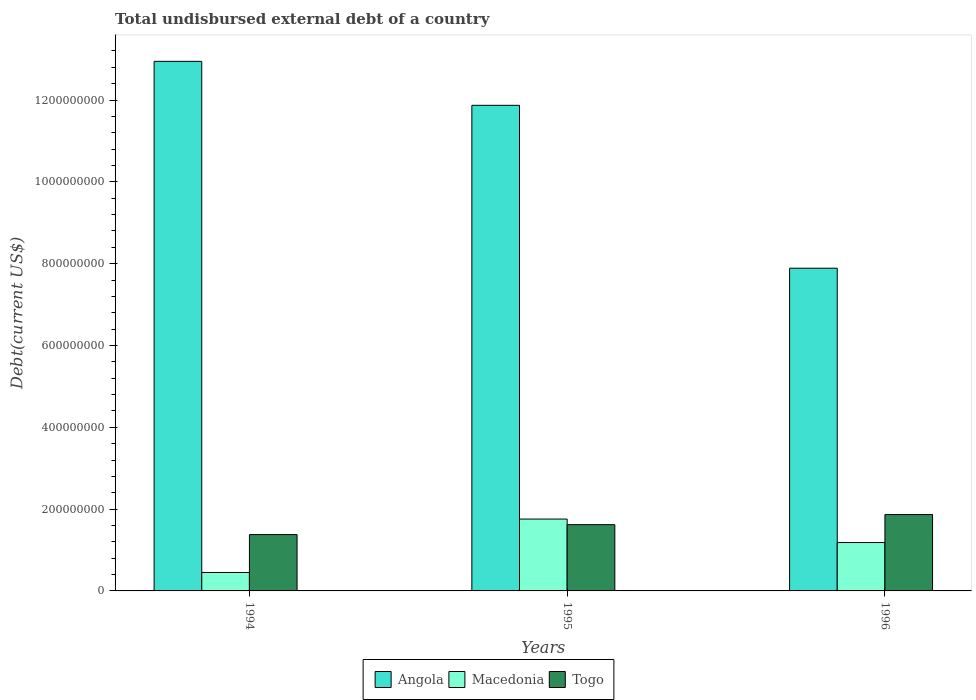How many different coloured bars are there?
Your answer should be very brief. 3. How many groups of bars are there?
Your response must be concise. 3. Are the number of bars per tick equal to the number of legend labels?
Your answer should be compact. Yes. Are the number of bars on each tick of the X-axis equal?
Ensure brevity in your answer.  Yes. How many bars are there on the 3rd tick from the right?
Your response must be concise. 3. What is the label of the 1st group of bars from the left?
Your answer should be compact. 1994. What is the total undisbursed external debt in Macedonia in 1996?
Offer a very short reply. 1.18e+08. Across all years, what is the maximum total undisbursed external debt in Togo?
Your answer should be compact. 1.87e+08. Across all years, what is the minimum total undisbursed external debt in Angola?
Ensure brevity in your answer.  7.89e+08. In which year was the total undisbursed external debt in Angola maximum?
Keep it short and to the point. 1994. What is the total total undisbursed external debt in Angola in the graph?
Provide a succinct answer. 3.27e+09. What is the difference between the total undisbursed external debt in Togo in 1994 and that in 1996?
Give a very brief answer. -4.90e+07. What is the difference between the total undisbursed external debt in Togo in 1994 and the total undisbursed external debt in Macedonia in 1995?
Offer a very short reply. -3.80e+07. What is the average total undisbursed external debt in Togo per year?
Offer a very short reply. 1.62e+08. In the year 1995, what is the difference between the total undisbursed external debt in Angola and total undisbursed external debt in Togo?
Provide a succinct answer. 1.03e+09. What is the ratio of the total undisbursed external debt in Macedonia in 1995 to that in 1996?
Provide a succinct answer. 1.49. Is the difference between the total undisbursed external debt in Angola in 1994 and 1996 greater than the difference between the total undisbursed external debt in Togo in 1994 and 1996?
Offer a very short reply. Yes. What is the difference between the highest and the second highest total undisbursed external debt in Togo?
Your answer should be compact. 2.47e+07. What is the difference between the highest and the lowest total undisbursed external debt in Macedonia?
Your answer should be compact. 1.31e+08. In how many years, is the total undisbursed external debt in Togo greater than the average total undisbursed external debt in Togo taken over all years?
Provide a short and direct response. 1. Is the sum of the total undisbursed external debt in Togo in 1994 and 1996 greater than the maximum total undisbursed external debt in Macedonia across all years?
Make the answer very short. Yes. What does the 3rd bar from the left in 1995 represents?
Give a very brief answer. Togo. What does the 2nd bar from the right in 1996 represents?
Offer a terse response. Macedonia. Is it the case that in every year, the sum of the total undisbursed external debt in Togo and total undisbursed external debt in Macedonia is greater than the total undisbursed external debt in Angola?
Keep it short and to the point. No. How many bars are there?
Keep it short and to the point. 9. What is the difference between two consecutive major ticks on the Y-axis?
Give a very brief answer. 2.00e+08. Does the graph contain any zero values?
Ensure brevity in your answer.  No. How many legend labels are there?
Make the answer very short. 3. What is the title of the graph?
Offer a very short reply. Total undisbursed external debt of a country. Does "Sub-Saharan Africa (developing only)" appear as one of the legend labels in the graph?
Ensure brevity in your answer.  No. What is the label or title of the Y-axis?
Your answer should be compact. Debt(current US$). What is the Debt(current US$) in Angola in 1994?
Give a very brief answer. 1.29e+09. What is the Debt(current US$) in Macedonia in 1994?
Your answer should be very brief. 4.51e+07. What is the Debt(current US$) in Togo in 1994?
Give a very brief answer. 1.38e+08. What is the Debt(current US$) in Angola in 1995?
Give a very brief answer. 1.19e+09. What is the Debt(current US$) of Macedonia in 1995?
Provide a short and direct response. 1.76e+08. What is the Debt(current US$) in Togo in 1995?
Ensure brevity in your answer.  1.62e+08. What is the Debt(current US$) in Angola in 1996?
Provide a succinct answer. 7.89e+08. What is the Debt(current US$) in Macedonia in 1996?
Keep it short and to the point. 1.18e+08. What is the Debt(current US$) in Togo in 1996?
Offer a very short reply. 1.87e+08. Across all years, what is the maximum Debt(current US$) in Angola?
Provide a short and direct response. 1.29e+09. Across all years, what is the maximum Debt(current US$) in Macedonia?
Give a very brief answer. 1.76e+08. Across all years, what is the maximum Debt(current US$) of Togo?
Keep it short and to the point. 1.87e+08. Across all years, what is the minimum Debt(current US$) in Angola?
Offer a terse response. 7.89e+08. Across all years, what is the minimum Debt(current US$) in Macedonia?
Your answer should be very brief. 4.51e+07. Across all years, what is the minimum Debt(current US$) of Togo?
Your response must be concise. 1.38e+08. What is the total Debt(current US$) in Angola in the graph?
Ensure brevity in your answer.  3.27e+09. What is the total Debt(current US$) in Macedonia in the graph?
Offer a very short reply. 3.39e+08. What is the total Debt(current US$) in Togo in the graph?
Your answer should be very brief. 4.86e+08. What is the difference between the Debt(current US$) of Angola in 1994 and that in 1995?
Offer a very short reply. 1.07e+08. What is the difference between the Debt(current US$) in Macedonia in 1994 and that in 1995?
Offer a very short reply. -1.31e+08. What is the difference between the Debt(current US$) in Togo in 1994 and that in 1995?
Your answer should be compact. -2.43e+07. What is the difference between the Debt(current US$) in Angola in 1994 and that in 1996?
Your answer should be compact. 5.06e+08. What is the difference between the Debt(current US$) in Macedonia in 1994 and that in 1996?
Offer a terse response. -7.32e+07. What is the difference between the Debt(current US$) of Togo in 1994 and that in 1996?
Give a very brief answer. -4.90e+07. What is the difference between the Debt(current US$) of Angola in 1995 and that in 1996?
Give a very brief answer. 3.98e+08. What is the difference between the Debt(current US$) in Macedonia in 1995 and that in 1996?
Keep it short and to the point. 5.74e+07. What is the difference between the Debt(current US$) of Togo in 1995 and that in 1996?
Keep it short and to the point. -2.47e+07. What is the difference between the Debt(current US$) of Angola in 1994 and the Debt(current US$) of Macedonia in 1995?
Ensure brevity in your answer.  1.12e+09. What is the difference between the Debt(current US$) of Angola in 1994 and the Debt(current US$) of Togo in 1995?
Your response must be concise. 1.13e+09. What is the difference between the Debt(current US$) in Macedonia in 1994 and the Debt(current US$) in Togo in 1995?
Give a very brief answer. -1.17e+08. What is the difference between the Debt(current US$) in Angola in 1994 and the Debt(current US$) in Macedonia in 1996?
Keep it short and to the point. 1.18e+09. What is the difference between the Debt(current US$) in Angola in 1994 and the Debt(current US$) in Togo in 1996?
Ensure brevity in your answer.  1.11e+09. What is the difference between the Debt(current US$) of Macedonia in 1994 and the Debt(current US$) of Togo in 1996?
Provide a short and direct response. -1.42e+08. What is the difference between the Debt(current US$) of Angola in 1995 and the Debt(current US$) of Macedonia in 1996?
Provide a short and direct response. 1.07e+09. What is the difference between the Debt(current US$) in Angola in 1995 and the Debt(current US$) in Togo in 1996?
Your answer should be very brief. 1.00e+09. What is the difference between the Debt(current US$) of Macedonia in 1995 and the Debt(current US$) of Togo in 1996?
Provide a succinct answer. -1.10e+07. What is the average Debt(current US$) in Angola per year?
Keep it short and to the point. 1.09e+09. What is the average Debt(current US$) in Macedonia per year?
Provide a succinct answer. 1.13e+08. What is the average Debt(current US$) in Togo per year?
Make the answer very short. 1.62e+08. In the year 1994, what is the difference between the Debt(current US$) of Angola and Debt(current US$) of Macedonia?
Offer a very short reply. 1.25e+09. In the year 1994, what is the difference between the Debt(current US$) in Angola and Debt(current US$) in Togo?
Keep it short and to the point. 1.16e+09. In the year 1994, what is the difference between the Debt(current US$) in Macedonia and Debt(current US$) in Togo?
Keep it short and to the point. -9.26e+07. In the year 1995, what is the difference between the Debt(current US$) in Angola and Debt(current US$) in Macedonia?
Provide a short and direct response. 1.01e+09. In the year 1995, what is the difference between the Debt(current US$) in Angola and Debt(current US$) in Togo?
Your response must be concise. 1.03e+09. In the year 1995, what is the difference between the Debt(current US$) of Macedonia and Debt(current US$) of Togo?
Make the answer very short. 1.37e+07. In the year 1996, what is the difference between the Debt(current US$) of Angola and Debt(current US$) of Macedonia?
Give a very brief answer. 6.71e+08. In the year 1996, what is the difference between the Debt(current US$) in Angola and Debt(current US$) in Togo?
Your response must be concise. 6.02e+08. In the year 1996, what is the difference between the Debt(current US$) of Macedonia and Debt(current US$) of Togo?
Keep it short and to the point. -6.84e+07. What is the ratio of the Debt(current US$) of Angola in 1994 to that in 1995?
Provide a short and direct response. 1.09. What is the ratio of the Debt(current US$) in Macedonia in 1994 to that in 1995?
Ensure brevity in your answer.  0.26. What is the ratio of the Debt(current US$) in Togo in 1994 to that in 1995?
Provide a succinct answer. 0.85. What is the ratio of the Debt(current US$) in Angola in 1994 to that in 1996?
Give a very brief answer. 1.64. What is the ratio of the Debt(current US$) in Macedonia in 1994 to that in 1996?
Your answer should be compact. 0.38. What is the ratio of the Debt(current US$) of Togo in 1994 to that in 1996?
Your answer should be very brief. 0.74. What is the ratio of the Debt(current US$) of Angola in 1995 to that in 1996?
Offer a terse response. 1.5. What is the ratio of the Debt(current US$) of Macedonia in 1995 to that in 1996?
Your answer should be compact. 1.49. What is the ratio of the Debt(current US$) in Togo in 1995 to that in 1996?
Make the answer very short. 0.87. What is the difference between the highest and the second highest Debt(current US$) of Angola?
Offer a very short reply. 1.07e+08. What is the difference between the highest and the second highest Debt(current US$) in Macedonia?
Offer a terse response. 5.74e+07. What is the difference between the highest and the second highest Debt(current US$) in Togo?
Your answer should be compact. 2.47e+07. What is the difference between the highest and the lowest Debt(current US$) in Angola?
Your answer should be very brief. 5.06e+08. What is the difference between the highest and the lowest Debt(current US$) in Macedonia?
Ensure brevity in your answer.  1.31e+08. What is the difference between the highest and the lowest Debt(current US$) in Togo?
Keep it short and to the point. 4.90e+07. 